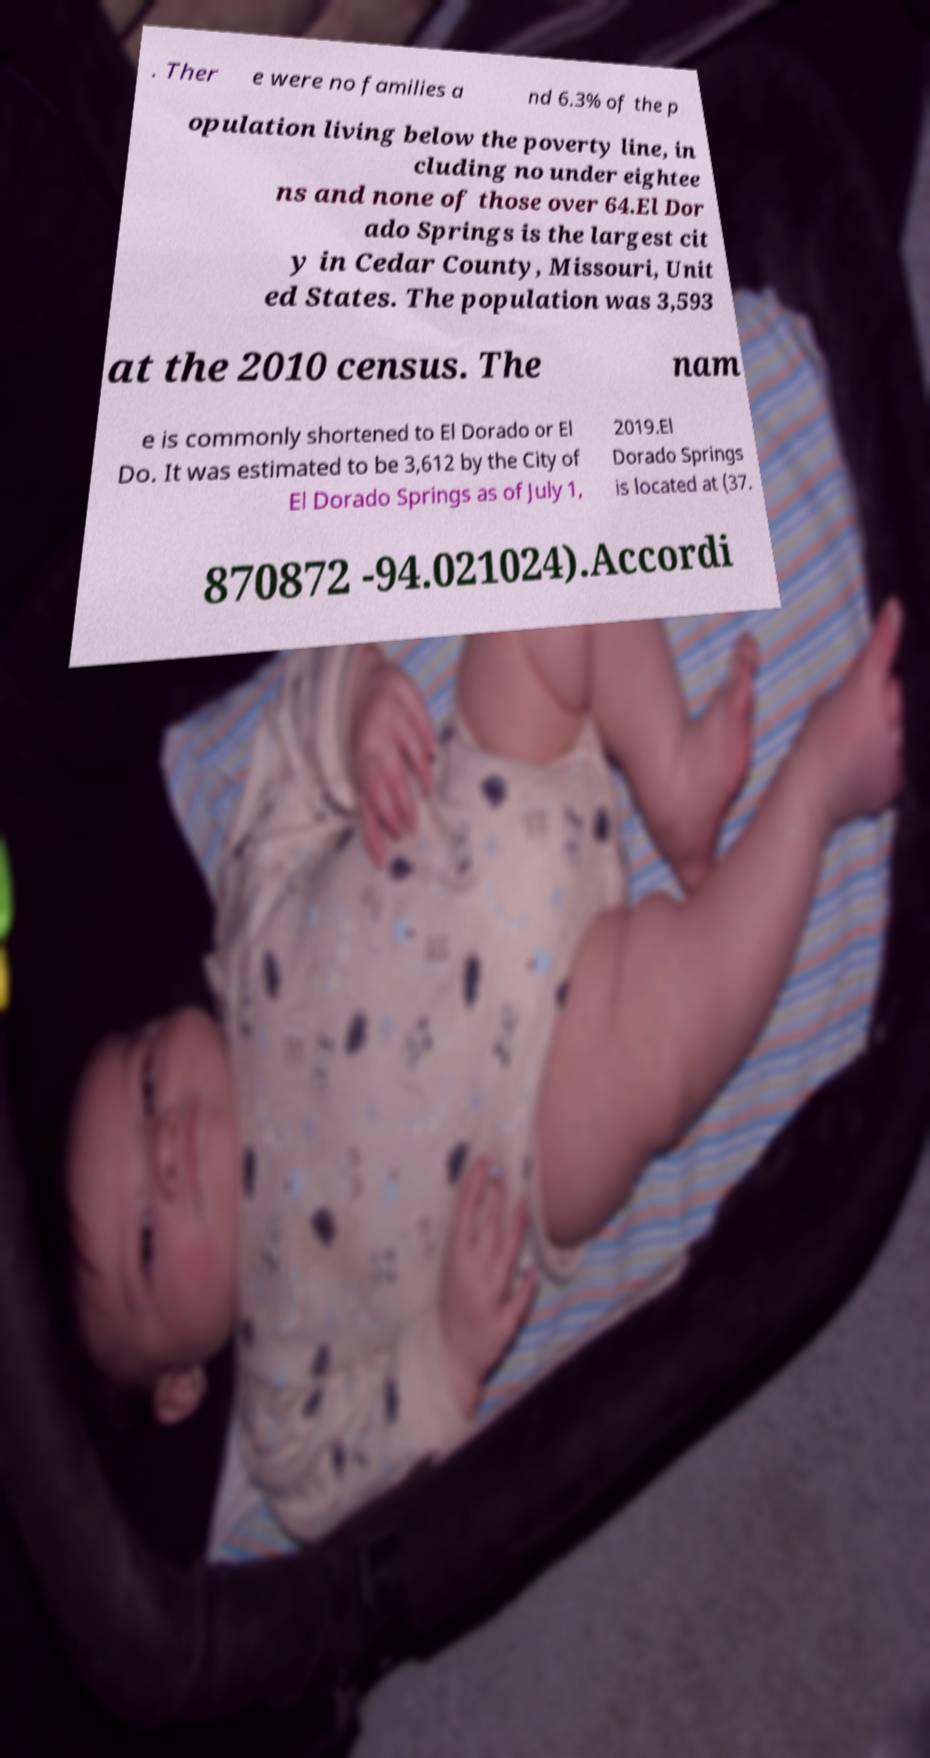Can you read and provide the text displayed in the image?This photo seems to have some interesting text. Can you extract and type it out for me? . Ther e were no families a nd 6.3% of the p opulation living below the poverty line, in cluding no under eightee ns and none of those over 64.El Dor ado Springs is the largest cit y in Cedar County, Missouri, Unit ed States. The population was 3,593 at the 2010 census. The nam e is commonly shortened to El Dorado or El Do. It was estimated to be 3,612 by the City of El Dorado Springs as of July 1, 2019.El Dorado Springs is located at (37. 870872 -94.021024).Accordi 